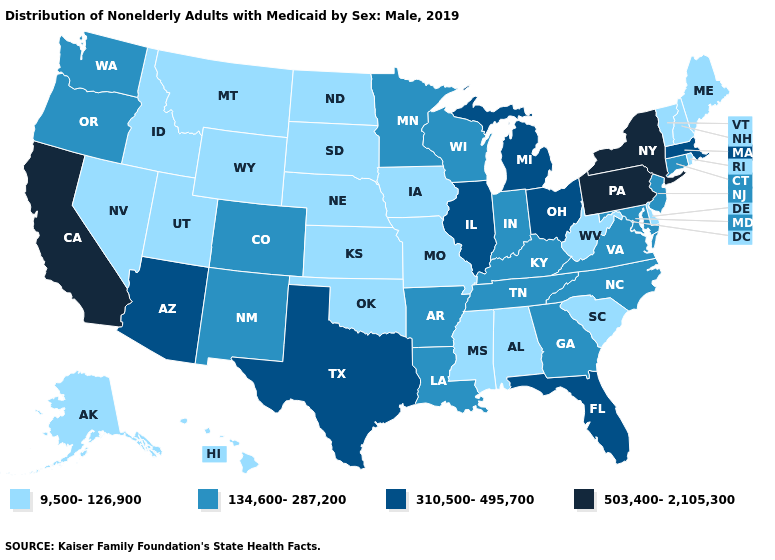Which states have the lowest value in the Northeast?
Give a very brief answer. Maine, New Hampshire, Rhode Island, Vermont. What is the value of New Mexico?
Answer briefly. 134,600-287,200. Is the legend a continuous bar?
Quick response, please. No. Among the states that border Connecticut , which have the highest value?
Write a very short answer. New York. Name the states that have a value in the range 134,600-287,200?
Answer briefly. Arkansas, Colorado, Connecticut, Georgia, Indiana, Kentucky, Louisiana, Maryland, Minnesota, New Jersey, New Mexico, North Carolina, Oregon, Tennessee, Virginia, Washington, Wisconsin. Name the states that have a value in the range 9,500-126,900?
Be succinct. Alabama, Alaska, Delaware, Hawaii, Idaho, Iowa, Kansas, Maine, Mississippi, Missouri, Montana, Nebraska, Nevada, New Hampshire, North Dakota, Oklahoma, Rhode Island, South Carolina, South Dakota, Utah, Vermont, West Virginia, Wyoming. Does the first symbol in the legend represent the smallest category?
Keep it brief. Yes. Name the states that have a value in the range 310,500-495,700?
Concise answer only. Arizona, Florida, Illinois, Massachusetts, Michigan, Ohio, Texas. How many symbols are there in the legend?
Answer briefly. 4. Which states hav the highest value in the West?
Answer briefly. California. Does Colorado have a higher value than New Mexico?
Keep it brief. No. What is the value of South Carolina?
Concise answer only. 9,500-126,900. What is the lowest value in the MidWest?
Answer briefly. 9,500-126,900. Does South Dakota have the lowest value in the MidWest?
Quick response, please. Yes. 